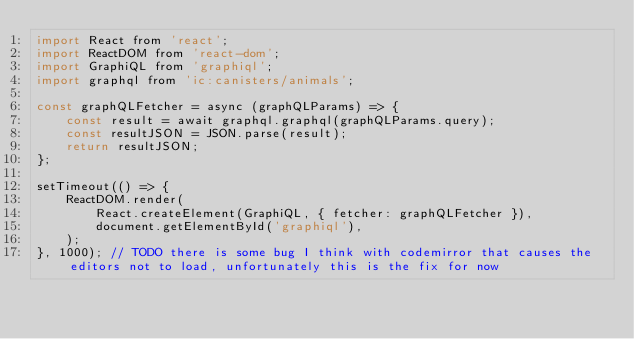Convert code to text. <code><loc_0><loc_0><loc_500><loc_500><_JavaScript_>import React from 'react';
import ReactDOM from 'react-dom';
import GraphiQL from 'graphiql';
import graphql from 'ic:canisters/animals';

const graphQLFetcher = async (graphQLParams) => {
    const result = await graphql.graphql(graphQLParams.query);
    const resultJSON = JSON.parse(result);
    return resultJSON;
};

setTimeout(() => {
    ReactDOM.render(
        React.createElement(GraphiQL, { fetcher: graphQLFetcher }),
        document.getElementById('graphiql'),
    );
}, 1000); // TODO there is some bug I think with codemirror that causes the editors not to load, unfortunately this is the fix for now
</code> 